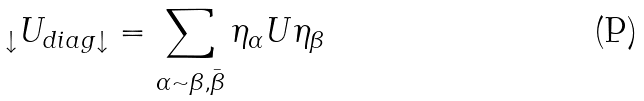<formula> <loc_0><loc_0><loc_500><loc_500>\ \, _ { \downarrow } U _ { d i a g \downarrow } = \sum _ { \alpha \sim \beta , \bar { \beta } } \eta _ { \alpha } U \eta _ { \beta }</formula> 